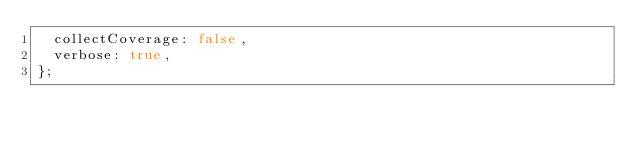<code> <loc_0><loc_0><loc_500><loc_500><_JavaScript_>  collectCoverage: false,
  verbose: true,
};
</code> 